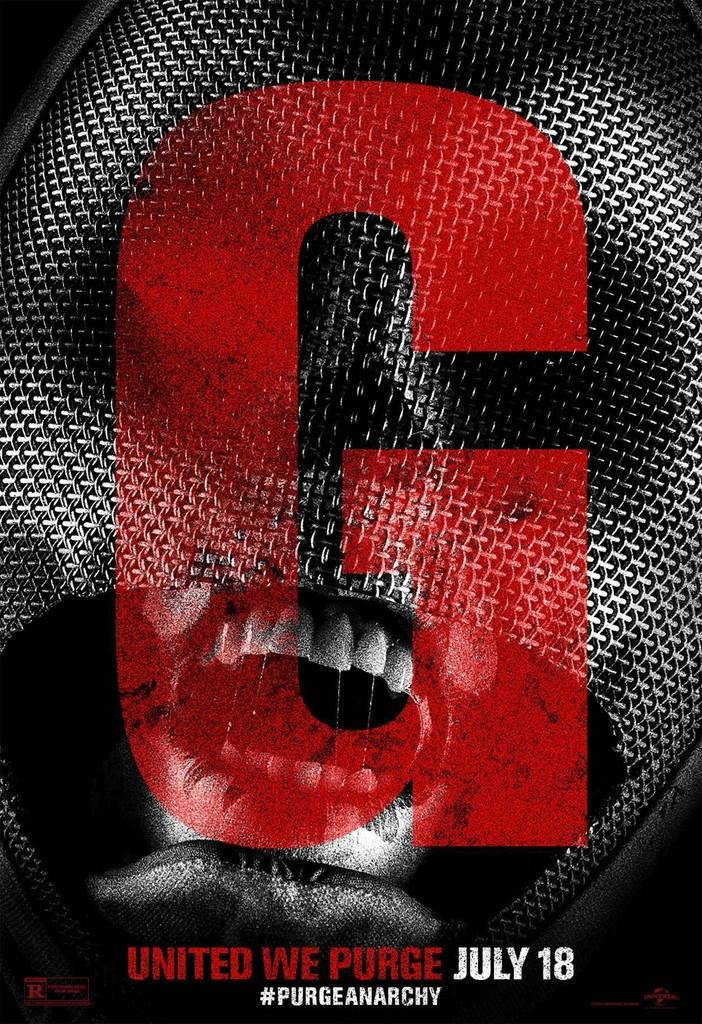Provide a one-sentence caption for the provided image. an ad for G United WE Purge on July 18. 